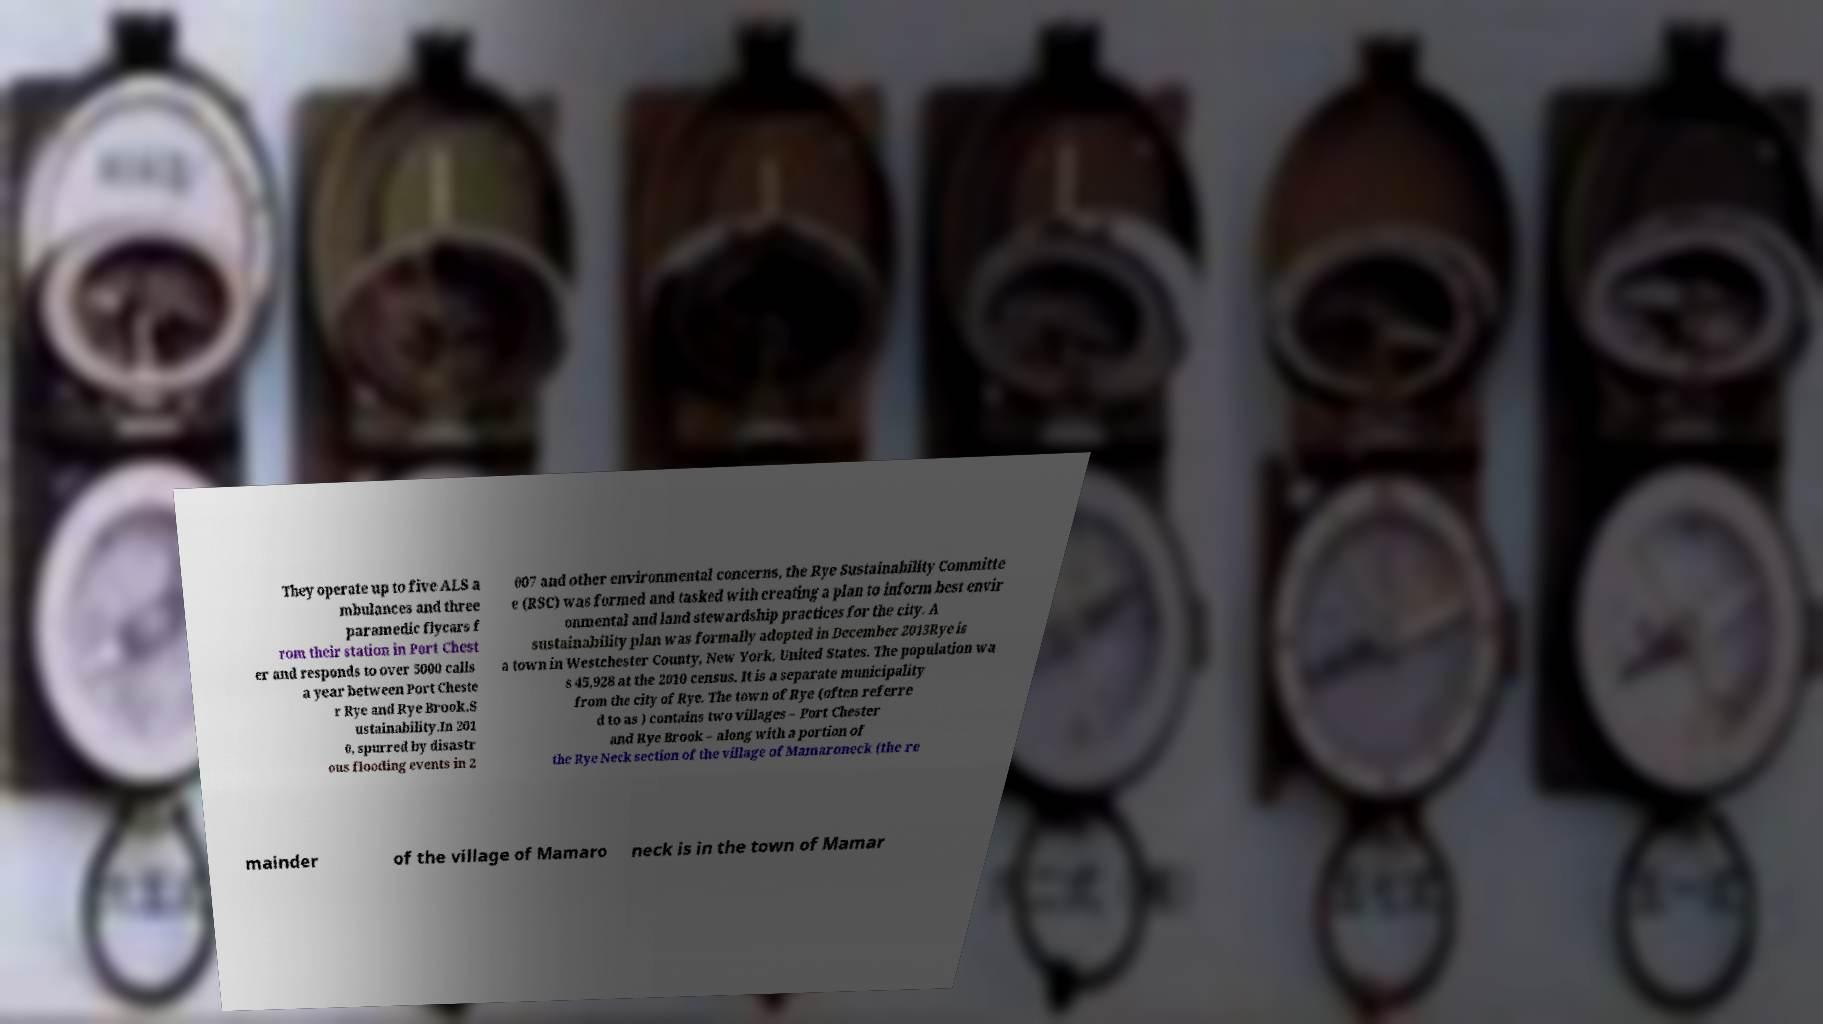Can you accurately transcribe the text from the provided image for me? They operate up to five ALS a mbulances and three paramedic flycars f rom their station in Port Chest er and responds to over 5000 calls a year between Port Cheste r Rye and Rye Brook.S ustainability.In 201 0, spurred by disastr ous flooding events in 2 007 and other environmental concerns, the Rye Sustainability Committe e (RSC) was formed and tasked with creating a plan to inform best envir onmental and land stewardship practices for the city. A sustainability plan was formally adopted in December 2013Rye is a town in Westchester County, New York, United States. The population wa s 45,928 at the 2010 census. It is a separate municipality from the city of Rye. The town of Rye (often referre d to as ) contains two villages – Port Chester and Rye Brook – along with a portion of the Rye Neck section of the village of Mamaroneck (the re mainder of the village of Mamaro neck is in the town of Mamar 